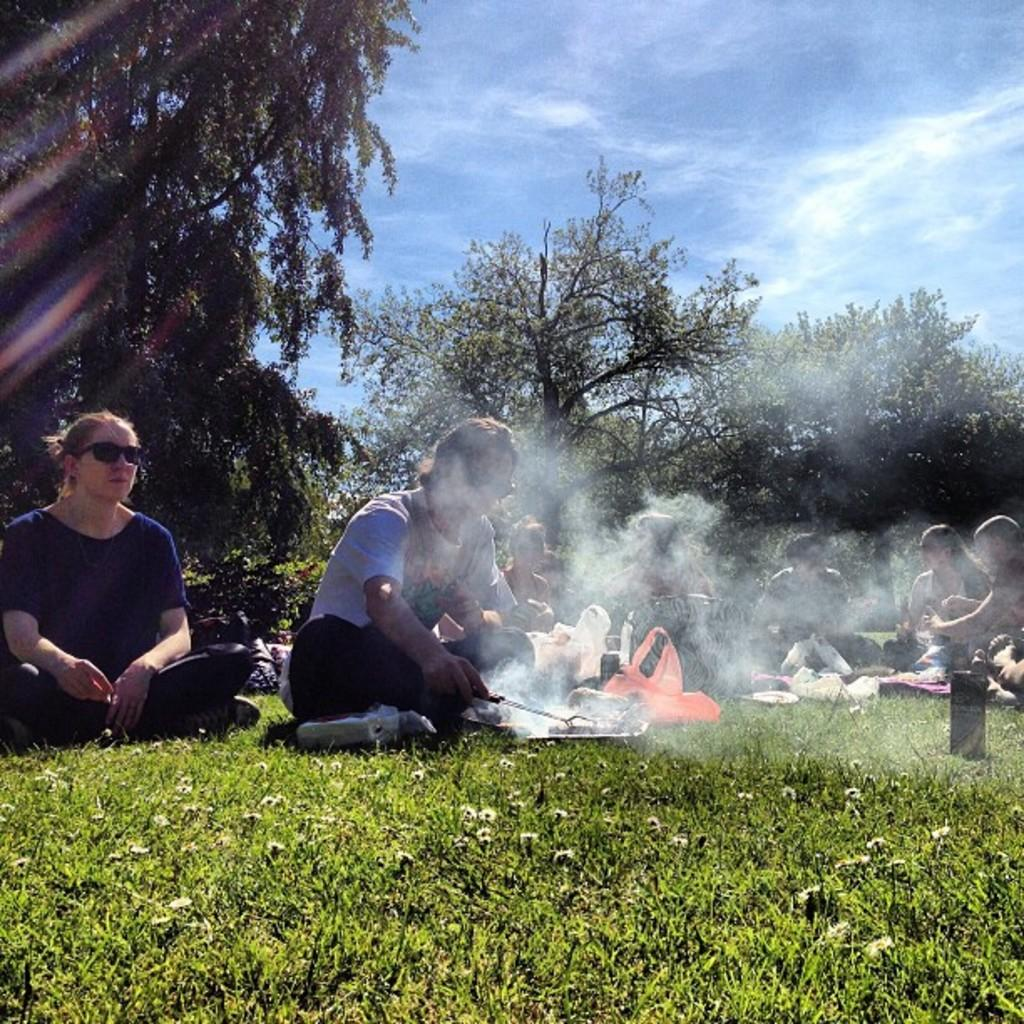What are the persons in the image doing? The persons in the image are sitting on the grass. What can be seen in the background of the image? There are trees and the sky visible in the background of the image. What is the condition of the sky in the image? Clouds are present in the sky. Where is the desk located in the image? There is no desk present in the image. How does the image convey a sense of quiet? The image does not convey a sense of quiet, as there is no information about the noise level or atmosphere in the image. 